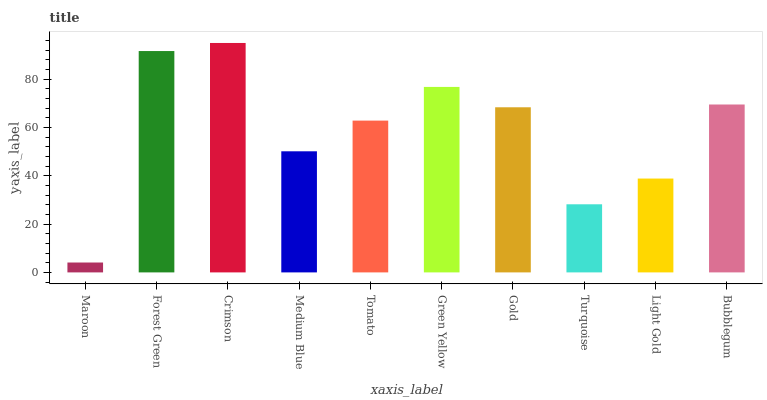Is Maroon the minimum?
Answer yes or no. Yes. Is Crimson the maximum?
Answer yes or no. Yes. Is Forest Green the minimum?
Answer yes or no. No. Is Forest Green the maximum?
Answer yes or no. No. Is Forest Green greater than Maroon?
Answer yes or no. Yes. Is Maroon less than Forest Green?
Answer yes or no. Yes. Is Maroon greater than Forest Green?
Answer yes or no. No. Is Forest Green less than Maroon?
Answer yes or no. No. Is Gold the high median?
Answer yes or no. Yes. Is Tomato the low median?
Answer yes or no. Yes. Is Light Gold the high median?
Answer yes or no. No. Is Crimson the low median?
Answer yes or no. No. 